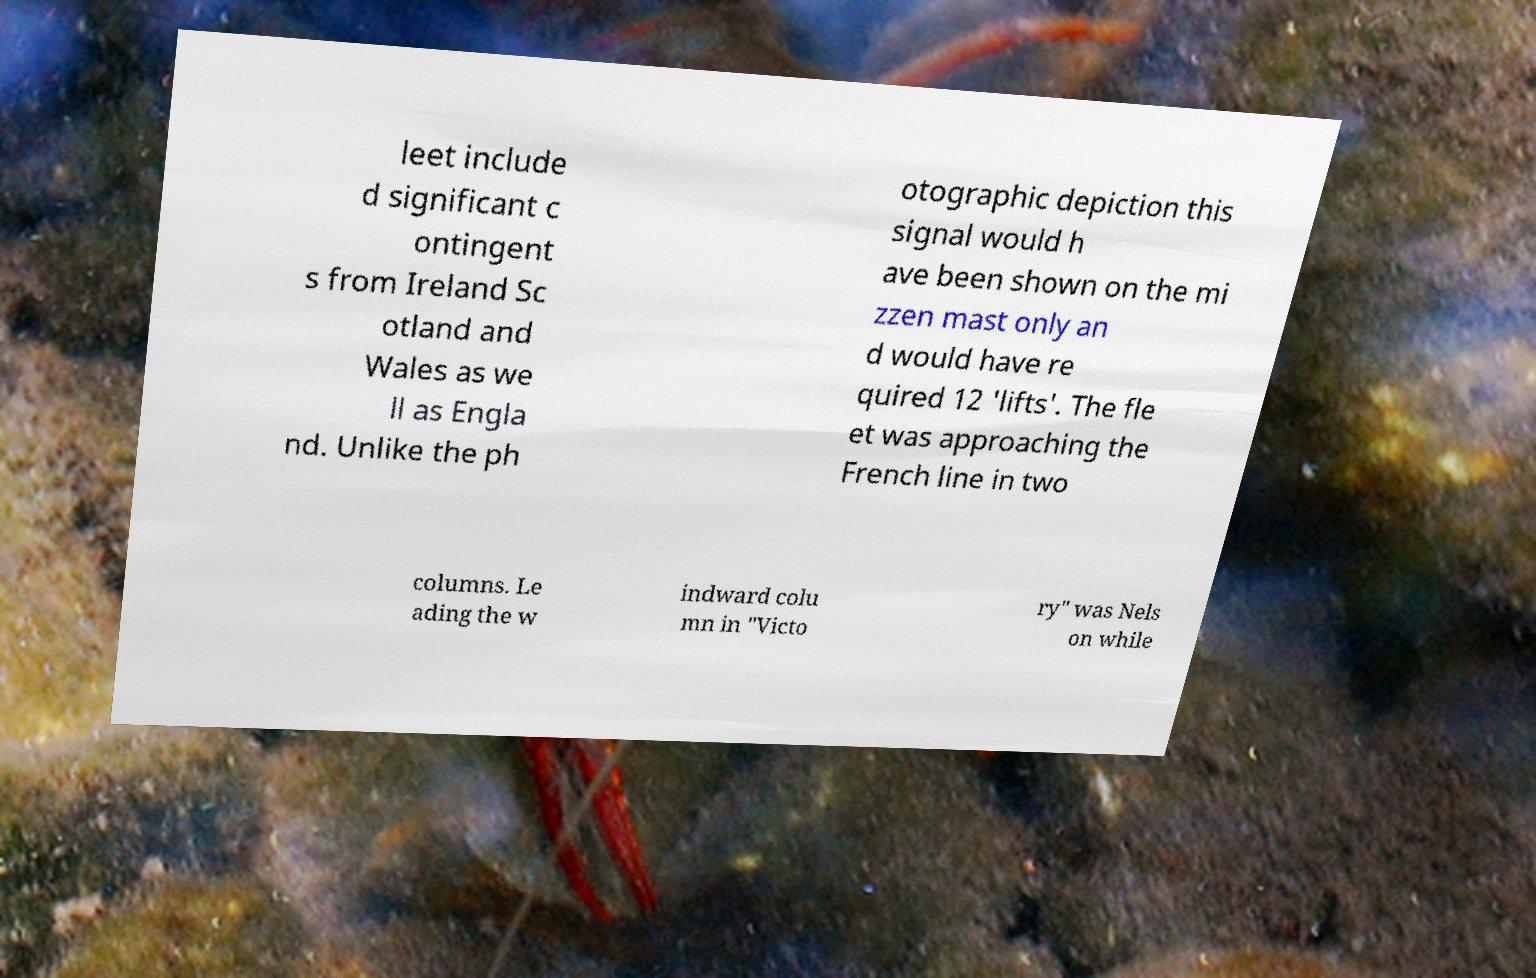Please read and relay the text visible in this image. What does it say? leet include d significant c ontingent s from Ireland Sc otland and Wales as we ll as Engla nd. Unlike the ph otographic depiction this signal would h ave been shown on the mi zzen mast only an d would have re quired 12 'lifts'. The fle et was approaching the French line in two columns. Le ading the w indward colu mn in "Victo ry" was Nels on while 